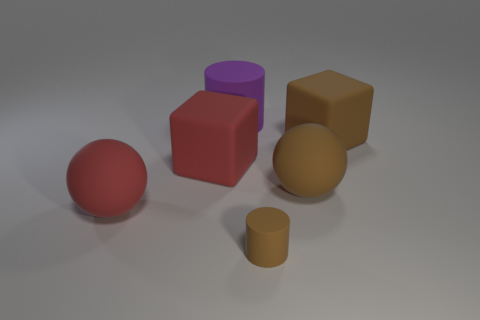Add 1 large things. How many objects exist? 7 Subtract all cylinders. How many objects are left? 4 Subtract 1 balls. How many balls are left? 1 Subtract all brown spheres. How many spheres are left? 1 Add 3 cubes. How many cubes are left? 5 Add 2 gray blocks. How many gray blocks exist? 2 Subtract 0 purple spheres. How many objects are left? 6 Subtract all red cubes. Subtract all purple spheres. How many cubes are left? 1 Subtract all green cubes. How many brown spheres are left? 1 Subtract all matte balls. Subtract all purple matte cylinders. How many objects are left? 3 